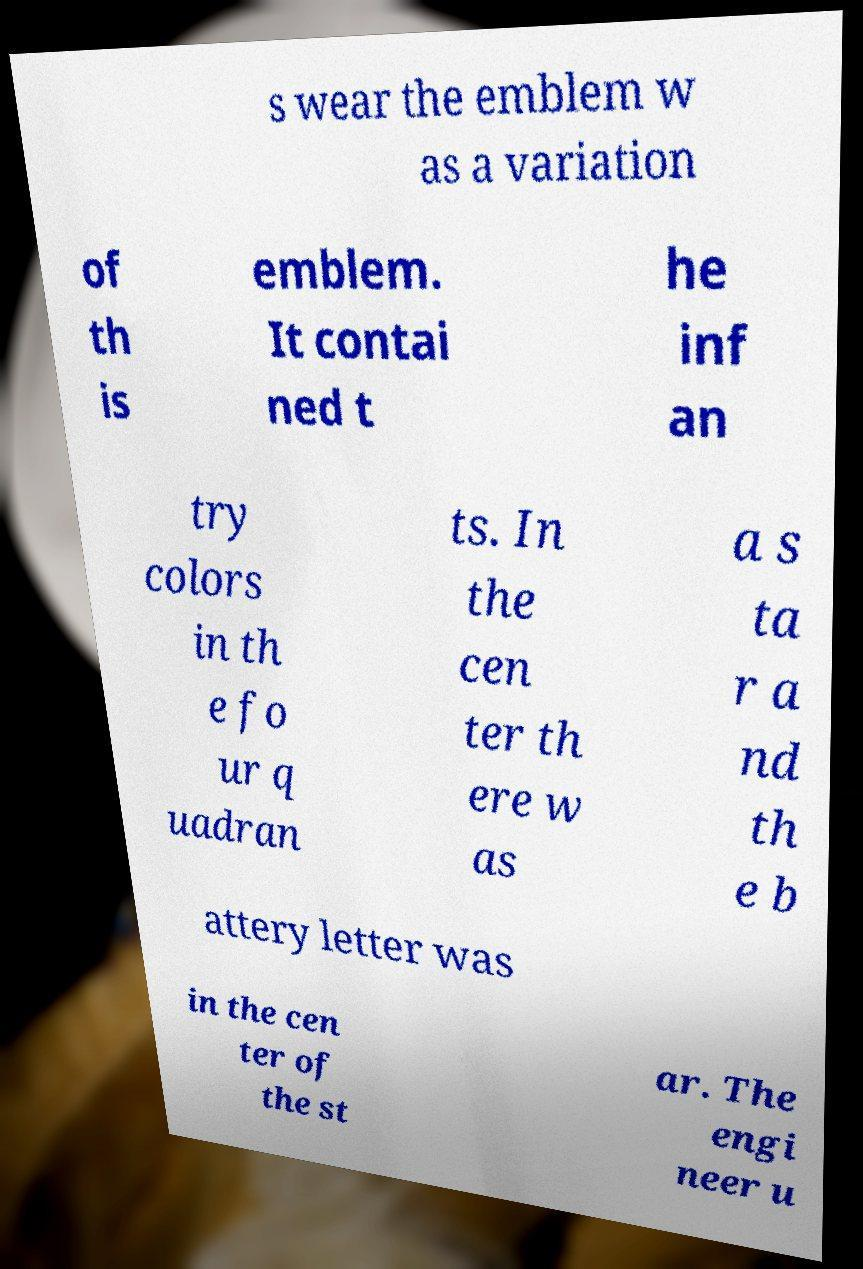Could you assist in decoding the text presented in this image and type it out clearly? s wear the emblem w as a variation of th is emblem. It contai ned t he inf an try colors in th e fo ur q uadran ts. In the cen ter th ere w as a s ta r a nd th e b attery letter was in the cen ter of the st ar. The engi neer u 